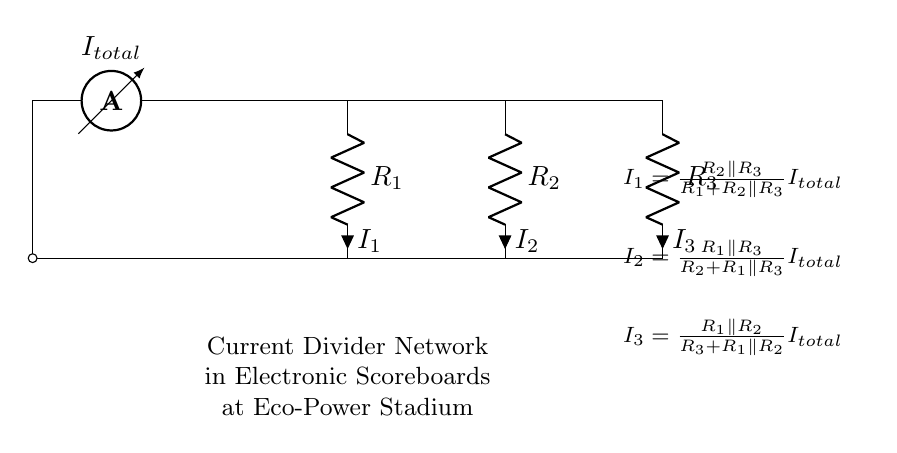What is the total current flowing in the circuit? The total current is denoted as I_{total}, which is indicated by the ammeter in the diagram. It represents the sum of currents flowing through the parallel resistors.
Answer: I_{total} How many resistors are in the current divider network? There are three resistors labeled R_1, R_2, and R_3 in the diagram, making up the current divider network.
Answer: 3 What is the current through resistor R_1? The current through R_1 is calculated using the formula I_1 = (R_2 parallel R_3) / (R_1 + R_2 parallel R_3) * I_{total}. This shows how the total current is divided based on the resistances.
Answer: I_1 Which component measures the total current in the circuit? The ammeter is the component used to measure the total current in the circuit, as shown in the diagram.
Answer: Ammeter What happens to the current in a current divider when one resistor value decreases? When a resistor value decreases, the current through that resistor increases because it results in a lower resistance, allowing more current to flow through it according to Ohm's law.
Answer: Increases How is the current divided between R_2 and R_3? The current is divided between R_2 and R_3 based on their parallel combination, which can be calculated using the formula I_2 = (R_1 parallel R_3) / (R_2 + R_1 parallel R_3) * I_{total}. This dependency highlights the relationship between the resistors and total current.
Answer: Based on parallel resistances What does the notation "R_2 parallel R_3" represent? The notation "R_2 parallel R_3" represents the equivalent resistance of resistors R_2 and R_3 when they are connected in parallel. This is crucial for determining current distribution in the current divider.
Answer: Equivalent resistance 